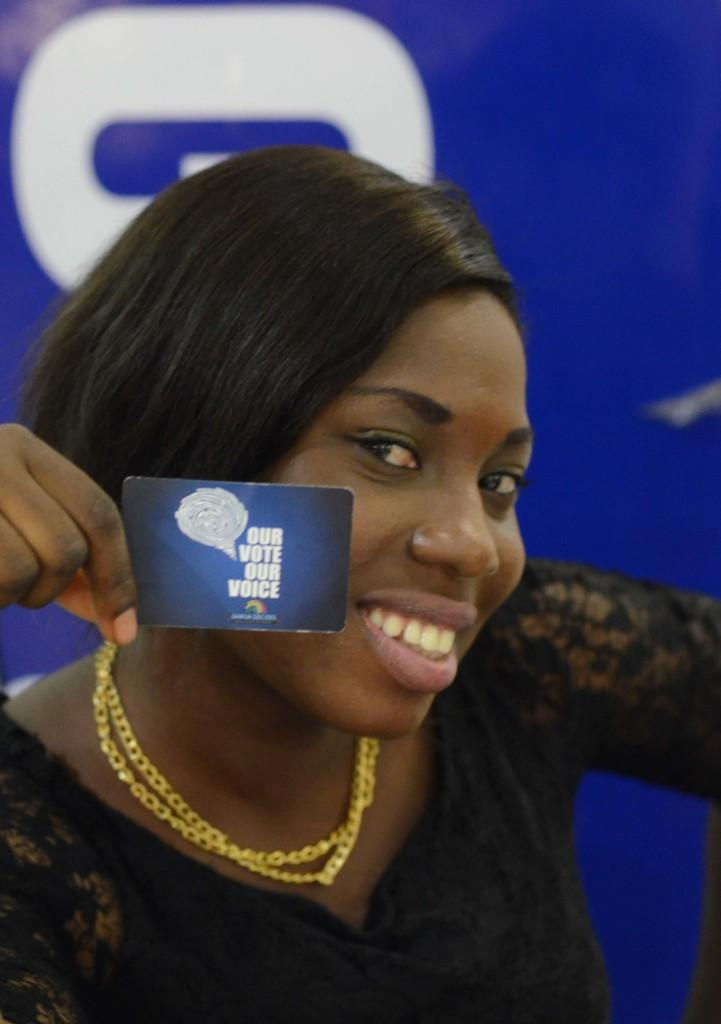Who is present in the image? There is a woman in the image. What is the woman doing in the image? The woman is smiling in the image. What is the woman holding in the image? The woman is holding a card in the image. What can be seen on the card? There is text on the card. What is visible in the background of the image? There is a banner in the background of the image. What type of toothbrush is the woman using in the image? There is no toothbrush present in the image. What drug is the woman taking in the image? There is no drug present in the image. 